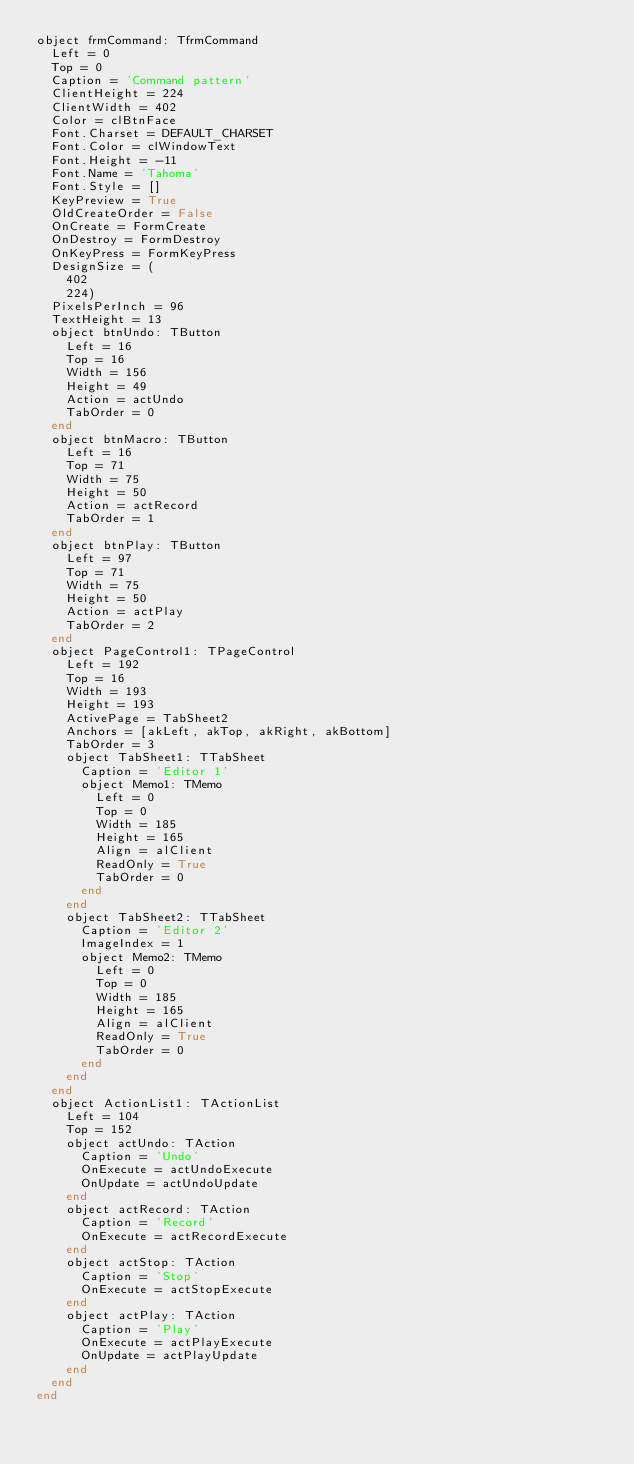Convert code to text. <code><loc_0><loc_0><loc_500><loc_500><_Pascal_>object frmCommand: TfrmCommand
  Left = 0
  Top = 0
  Caption = 'Command pattern'
  ClientHeight = 224
  ClientWidth = 402
  Color = clBtnFace
  Font.Charset = DEFAULT_CHARSET
  Font.Color = clWindowText
  Font.Height = -11
  Font.Name = 'Tahoma'
  Font.Style = []
  KeyPreview = True
  OldCreateOrder = False
  OnCreate = FormCreate
  OnDestroy = FormDestroy
  OnKeyPress = FormKeyPress
  DesignSize = (
    402
    224)
  PixelsPerInch = 96
  TextHeight = 13
  object btnUndo: TButton
    Left = 16
    Top = 16
    Width = 156
    Height = 49
    Action = actUndo
    TabOrder = 0
  end
  object btnMacro: TButton
    Left = 16
    Top = 71
    Width = 75
    Height = 50
    Action = actRecord
    TabOrder = 1
  end
  object btnPlay: TButton
    Left = 97
    Top = 71
    Width = 75
    Height = 50
    Action = actPlay
    TabOrder = 2
  end
  object PageControl1: TPageControl
    Left = 192
    Top = 16
    Width = 193
    Height = 193
    ActivePage = TabSheet2
    Anchors = [akLeft, akTop, akRight, akBottom]
    TabOrder = 3
    object TabSheet1: TTabSheet
      Caption = 'Editor 1'
      object Memo1: TMemo
        Left = 0
        Top = 0
        Width = 185
        Height = 165
        Align = alClient
        ReadOnly = True
        TabOrder = 0
      end
    end
    object TabSheet2: TTabSheet
      Caption = 'Editor 2'
      ImageIndex = 1
      object Memo2: TMemo
        Left = 0
        Top = 0
        Width = 185
        Height = 165
        Align = alClient
        ReadOnly = True
        TabOrder = 0
      end
    end
  end
  object ActionList1: TActionList
    Left = 104
    Top = 152
    object actUndo: TAction
      Caption = 'Undo'
      OnExecute = actUndoExecute
      OnUpdate = actUndoUpdate
    end
    object actRecord: TAction
      Caption = 'Record'
      OnExecute = actRecordExecute
    end
    object actStop: TAction
      Caption = 'Stop'
      OnExecute = actStopExecute
    end
    object actPlay: TAction
      Caption = 'Play'
      OnExecute = actPlayExecute
      OnUpdate = actPlayUpdate
    end
  end
end
</code> 